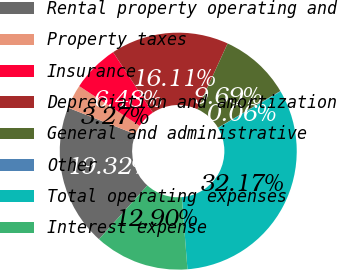<chart> <loc_0><loc_0><loc_500><loc_500><pie_chart><fcel>Rental property operating and<fcel>Property taxes<fcel>Insurance<fcel>Depreciation and amortization<fcel>General and administrative<fcel>Other<fcel>Total operating expenses<fcel>Interest expense<nl><fcel>19.32%<fcel>3.27%<fcel>6.48%<fcel>16.11%<fcel>9.69%<fcel>0.06%<fcel>32.17%<fcel>12.9%<nl></chart> 